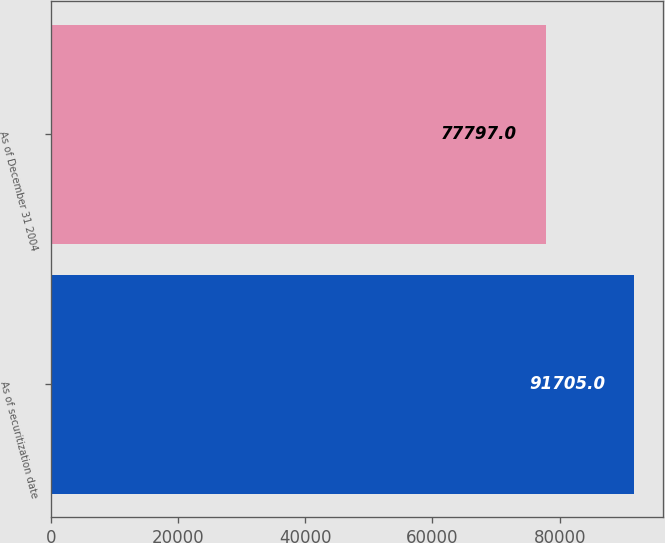Convert chart. <chart><loc_0><loc_0><loc_500><loc_500><bar_chart><fcel>As of securitization date<fcel>As of December 31 2004<nl><fcel>91705<fcel>77797<nl></chart> 